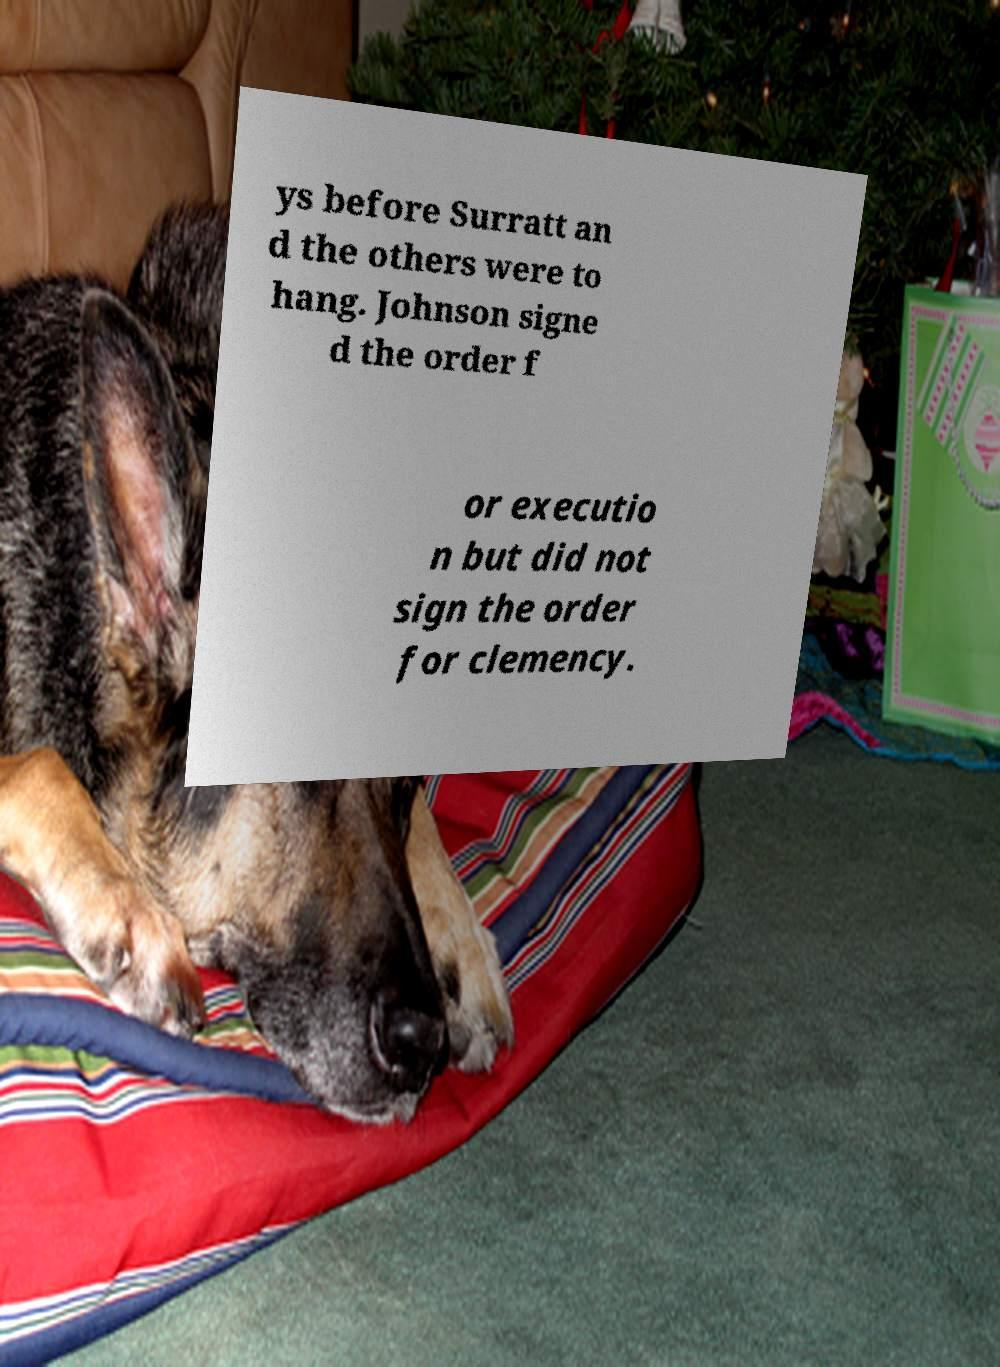Can you read and provide the text displayed in the image?This photo seems to have some interesting text. Can you extract and type it out for me? ys before Surratt an d the others were to hang. Johnson signe d the order f or executio n but did not sign the order for clemency. 